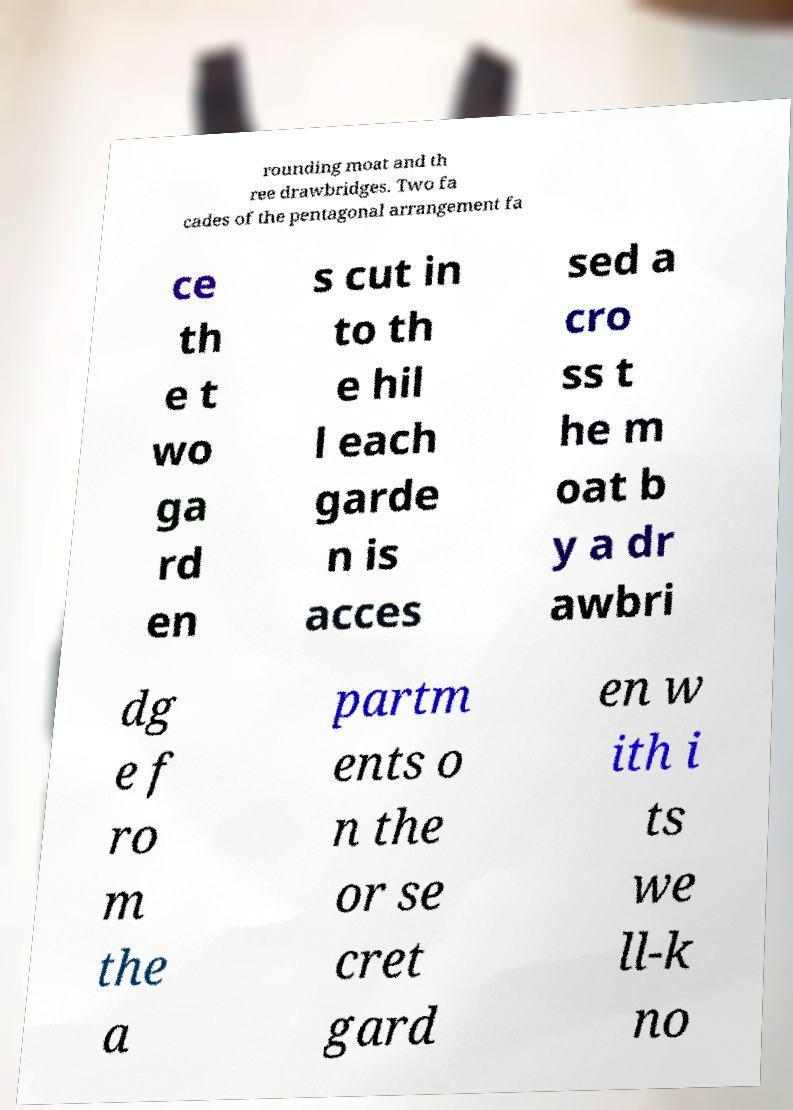For documentation purposes, I need the text within this image transcribed. Could you provide that? rounding moat and th ree drawbridges. Two fa cades of the pentagonal arrangement fa ce th e t wo ga rd en s cut in to th e hil l each garde n is acces sed a cro ss t he m oat b y a dr awbri dg e f ro m the a partm ents o n the or se cret gard en w ith i ts we ll-k no 